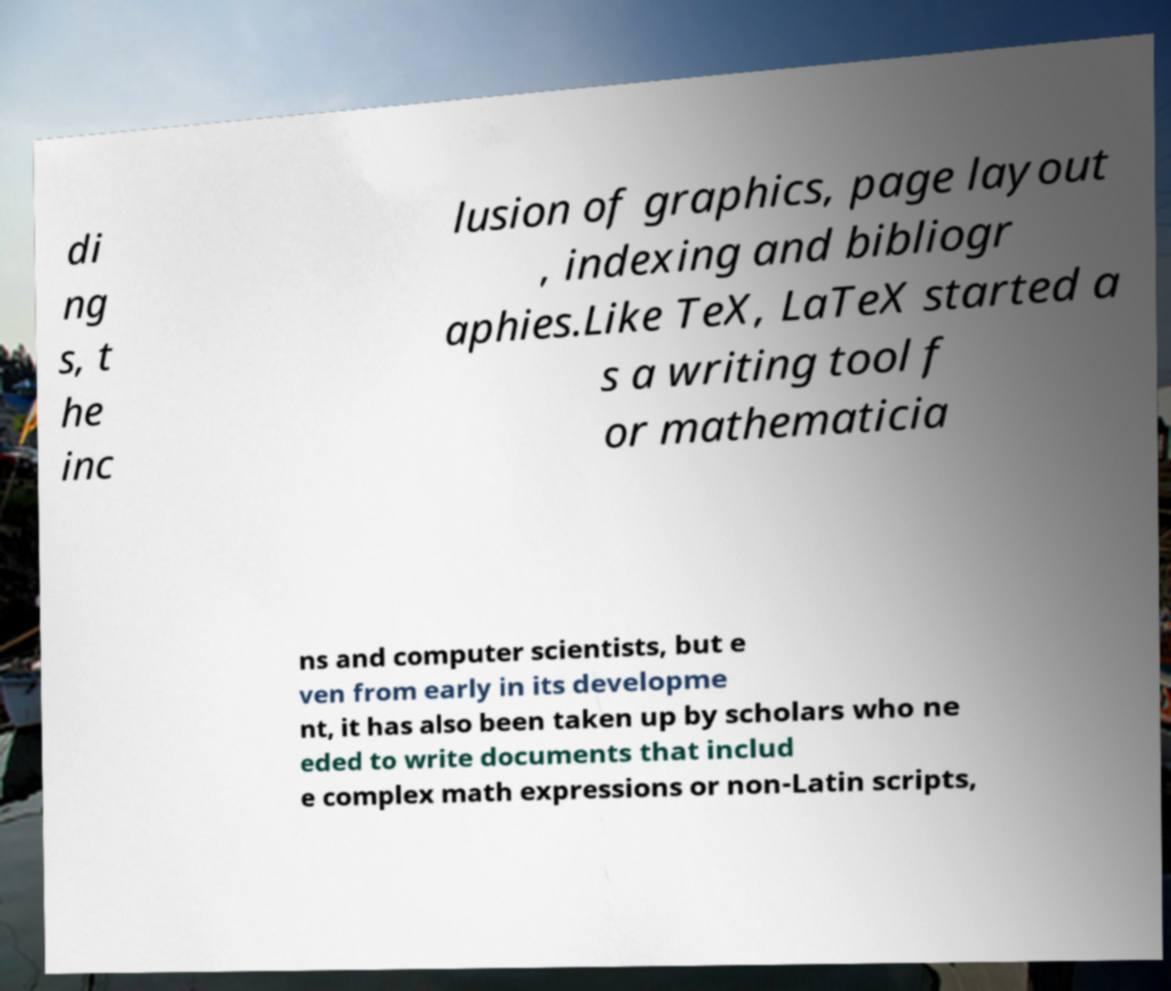Can you read and provide the text displayed in the image?This photo seems to have some interesting text. Can you extract and type it out for me? di ng s, t he inc lusion of graphics, page layout , indexing and bibliogr aphies.Like TeX, LaTeX started a s a writing tool f or mathematicia ns and computer scientists, but e ven from early in its developme nt, it has also been taken up by scholars who ne eded to write documents that includ e complex math expressions or non-Latin scripts, 